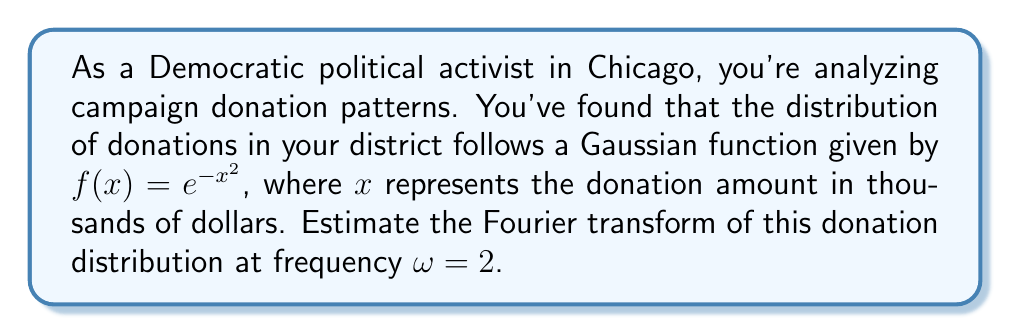What is the answer to this math problem? To solve this problem, we need to calculate the Fourier transform of the given Gaussian function at $\omega = 2$. The Fourier transform of a function $f(x)$ is defined as:

$$F(\omega) = \int_{-\infty}^{\infty} f(x) e^{-i\omega x} dx$$

For our Gaussian function $f(x) = e^{-x^2}$, the Fourier transform is known to be:

$$F(\omega) = \sqrt{\pi} e^{-\frac{\omega^2}{4}}$$

This is a well-known result in Fourier analysis. To estimate the Fourier transform at $\omega = 2$, we simply substitute this value:

$$F(2) = \sqrt{\pi} e^{-\frac{2^2}{4}} = \sqrt{\pi} e^{-1}$$

Now, let's calculate this value:

1) First, calculate $e^{-1}$:
   $e^{-1} \approx 0.3678794$

2) Then, multiply by $\sqrt{\pi}$:
   $\sqrt{\pi} \approx 1.7724539$
   
   $\sqrt{\pi} \cdot e^{-1} \approx 1.7724539 \cdot 0.3678794 \approx 0.6521451$

This result represents the magnitude of the Fourier transform at $\omega = 2$, which indicates the strength of the frequency component corresponding to donation patterns that oscillate twice per thousand dollars.
Answer: $F(2) = \sqrt{\pi} e^{-1} \approx 0.6521451$ 